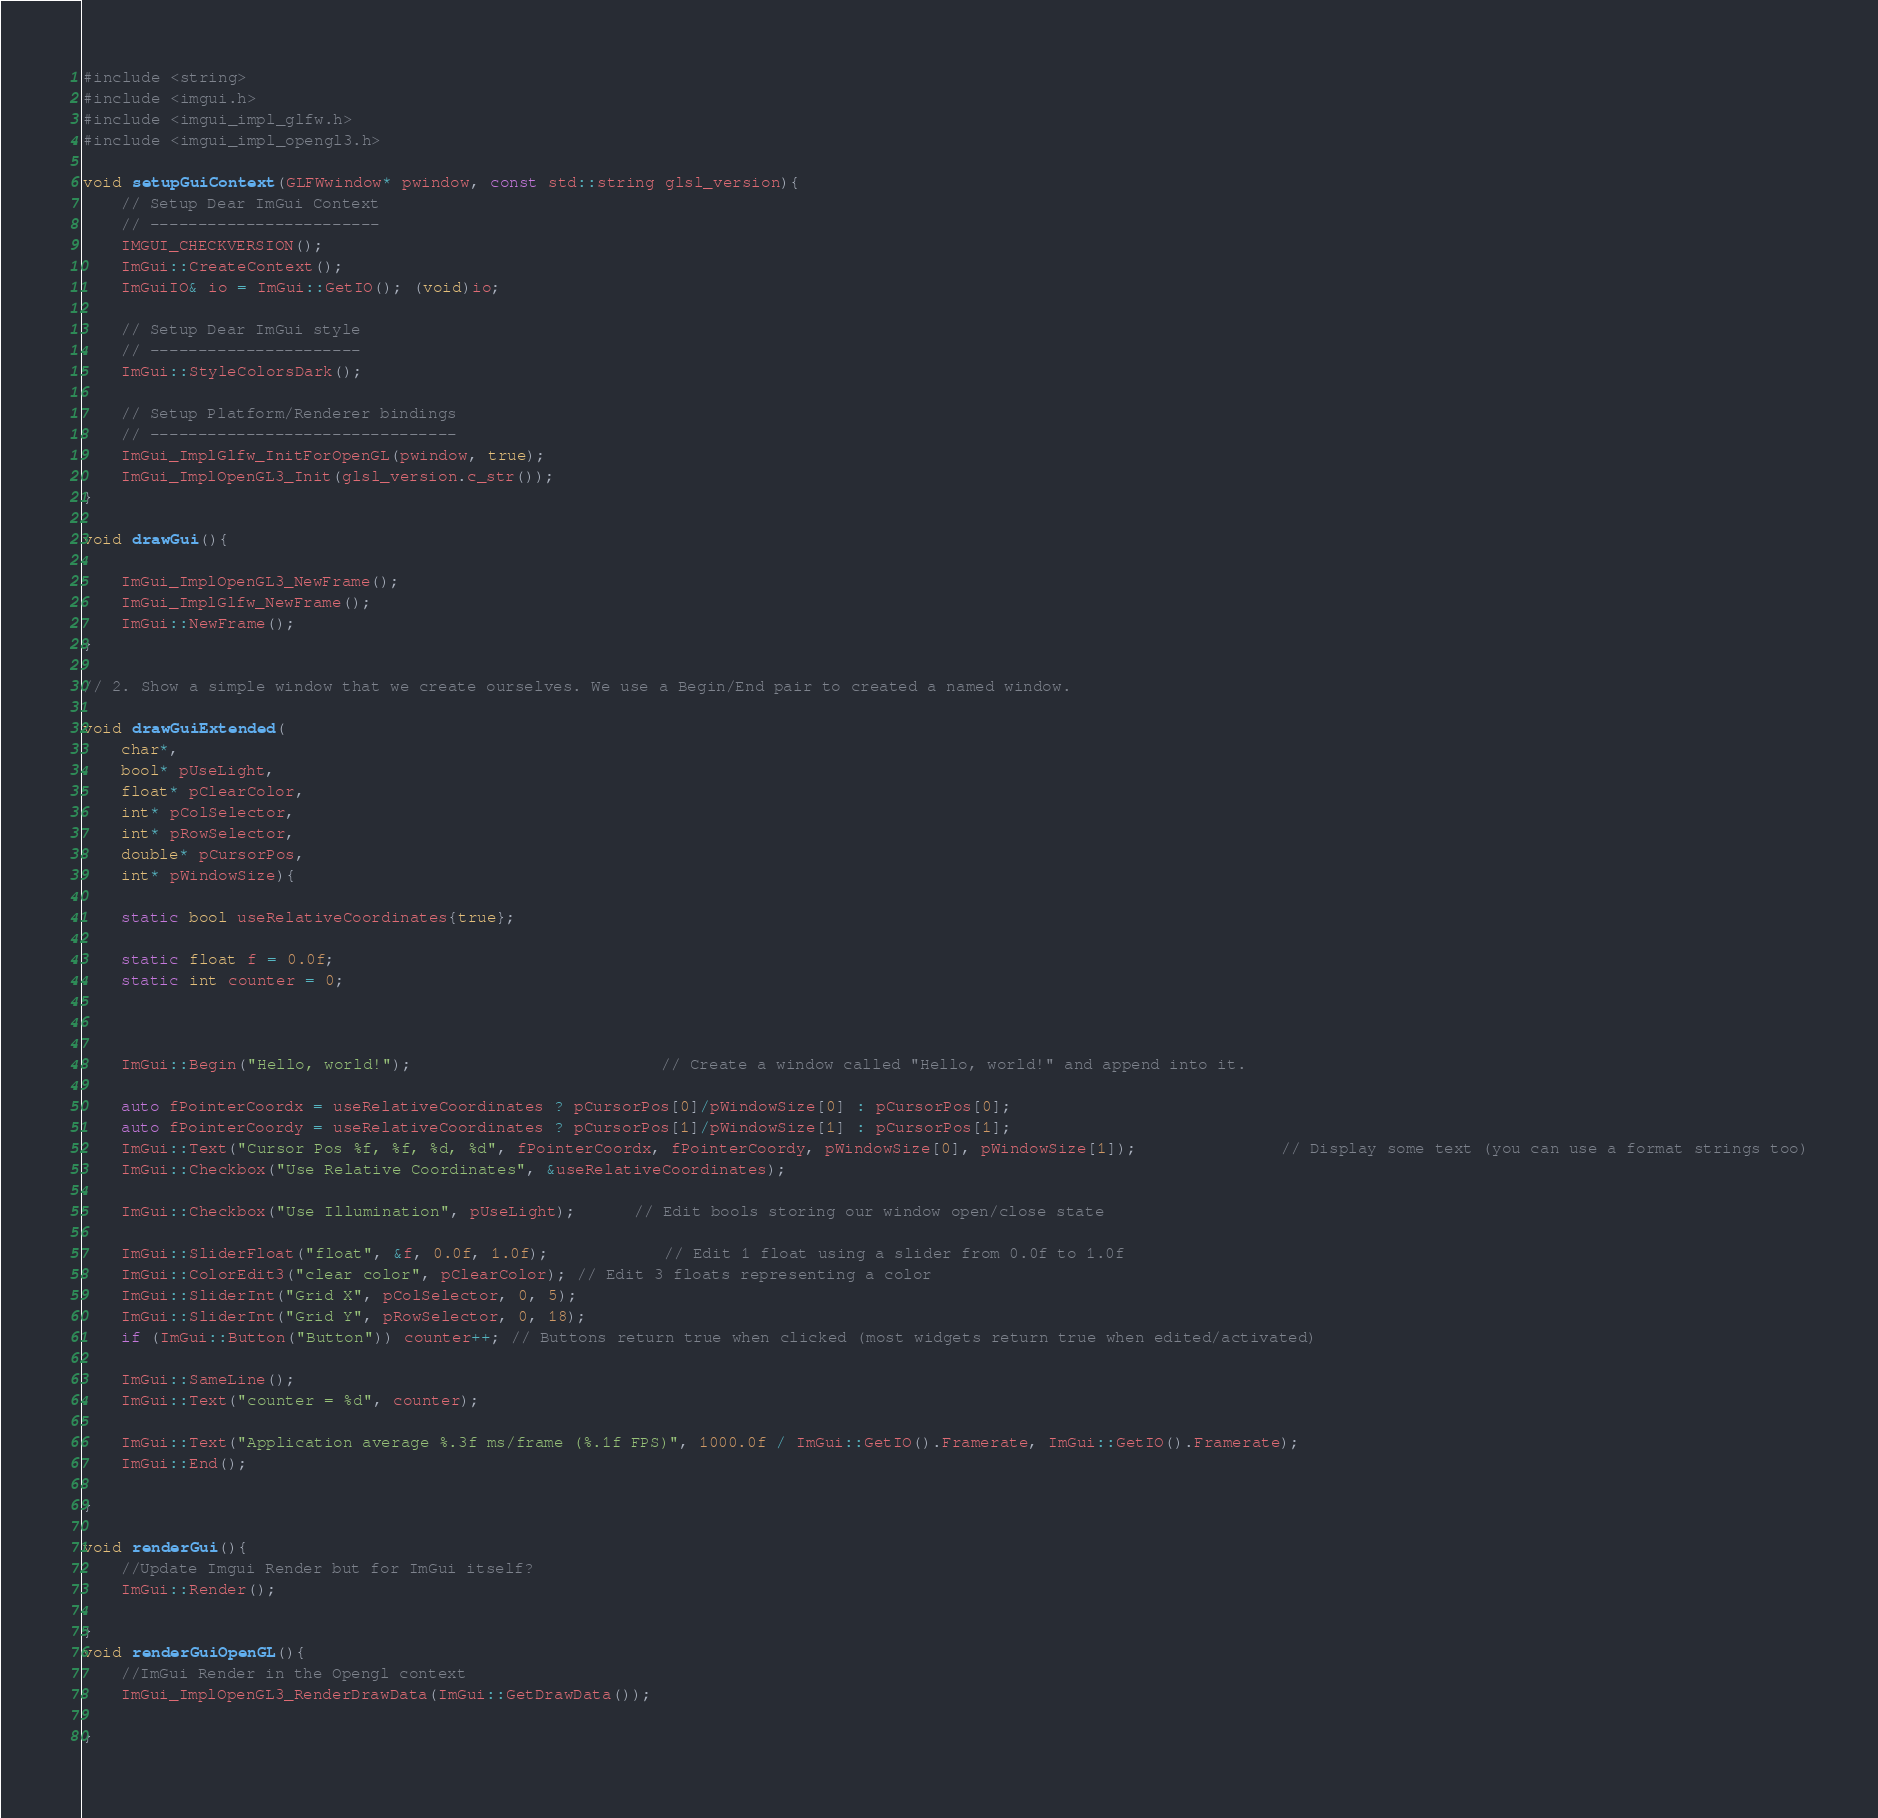Convert code to text. <code><loc_0><loc_0><loc_500><loc_500><_C++_>#include <string>
#include <imgui.h>  
#include <imgui_impl_glfw.h>
#include <imgui_impl_opengl3.h>

void setupGuiContext(GLFWwindow* pwindow, const std::string glsl_version){
    // Setup Dear ImGui Context
    // ------------------------
    IMGUI_CHECKVERSION();
    ImGui::CreateContext();
    ImGuiIO& io = ImGui::GetIO(); (void)io;

    // Setup Dear ImGui style
    // ----------------------
    ImGui::StyleColorsDark();

    // Setup Platform/Renderer bindings
    // --------------------------------
    ImGui_ImplGlfw_InitForOpenGL(pwindow, true);
    ImGui_ImplOpenGL3_Init(glsl_version.c_str());
}

void drawGui(){

    ImGui_ImplOpenGL3_NewFrame();
    ImGui_ImplGlfw_NewFrame();
    ImGui::NewFrame();  
}

// 2. Show a simple window that we create ourselves. We use a Begin/End pair to created a named window.
        
void drawGuiExtended(
    char*,
    bool* pUseLight,
    float* pClearColor,
    int* pColSelector,
    int* pRowSelector,
    double* pCursorPos,
    int* pWindowSize){
    
    static bool useRelativeCoordinates{true};
    
    static float f = 0.0f;
    static int counter = 0;



    ImGui::Begin("Hello, world!");                          // Create a window called "Hello, world!" and append into it.
    
    auto fPointerCoordx = useRelativeCoordinates ? pCursorPos[0]/pWindowSize[0] : pCursorPos[0];
    auto fPointerCoordy = useRelativeCoordinates ? pCursorPos[1]/pWindowSize[1] : pCursorPos[1];
    ImGui::Text("Cursor Pos %f, %f, %d, %d", fPointerCoordx, fPointerCoordy, pWindowSize[0], pWindowSize[1]);               // Display some text (you can use a format strings too)
    ImGui::Checkbox("Use Relative Coordinates", &useRelativeCoordinates);
    
    ImGui::Checkbox("Use Illumination", pUseLight);      // Edit bools storing our window open/close state
    
    ImGui::SliderFloat("float", &f, 0.0f, 1.0f);            // Edit 1 float using a slider from 0.0f to 1.0f
    ImGui::ColorEdit3("clear color", pClearColor); // Edit 3 floats representing a color
    ImGui::SliderInt("Grid X", pColSelector, 0, 5);
    ImGui::SliderInt("Grid Y", pRowSelector, 0, 18);    
    if (ImGui::Button("Button")) counter++; // Buttons return true when clicked (most widgets return true when edited/activated)
                
    ImGui::SameLine();
    ImGui::Text("counter = %d", counter);

    ImGui::Text("Application average %.3f ms/frame (%.1f FPS)", 1000.0f / ImGui::GetIO().Framerate, ImGui::GetIO().Framerate);
    ImGui::End();

}

void renderGui(){
    //Update Imgui Render but for ImGui itself?
    ImGui::Render();

}
void renderGuiOpenGL(){
    //ImGui Render in the Opengl context
    ImGui_ImplOpenGL3_RenderDrawData(ImGui::GetDrawData());
        
}
</code> 